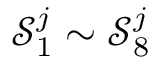<formula> <loc_0><loc_0><loc_500><loc_500>\mathcal { S } _ { 1 } ^ { j } \sim \mathcal { S } _ { 8 } ^ { j }</formula> 